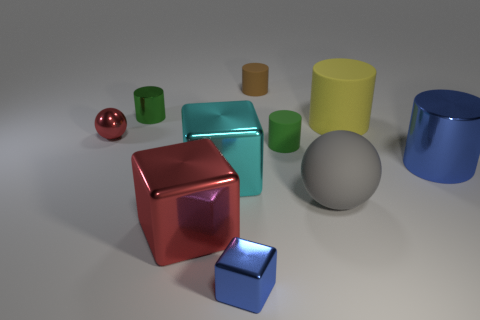Can you infer anything about the setting from the arrangement of the objects? The arrangement of the objects appears deliberate, like a setup for an art installation or a 3D modeling render. It seems to be an indoor setting, suggested by the soft shadows and controlled lighting, possibly designed for displaying the objects' shapes, colors, and materials. 